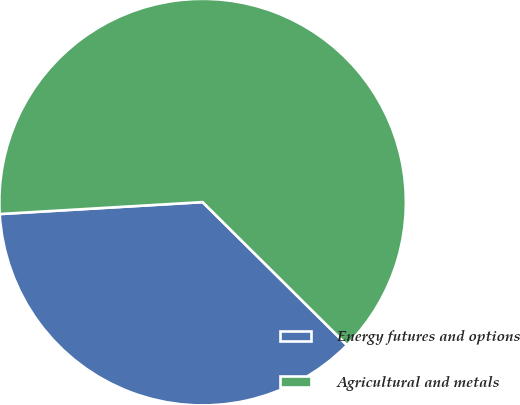<chart> <loc_0><loc_0><loc_500><loc_500><pie_chart><fcel>Energy futures and options<fcel>Agricultural and metals<nl><fcel>36.64%<fcel>63.36%<nl></chart> 